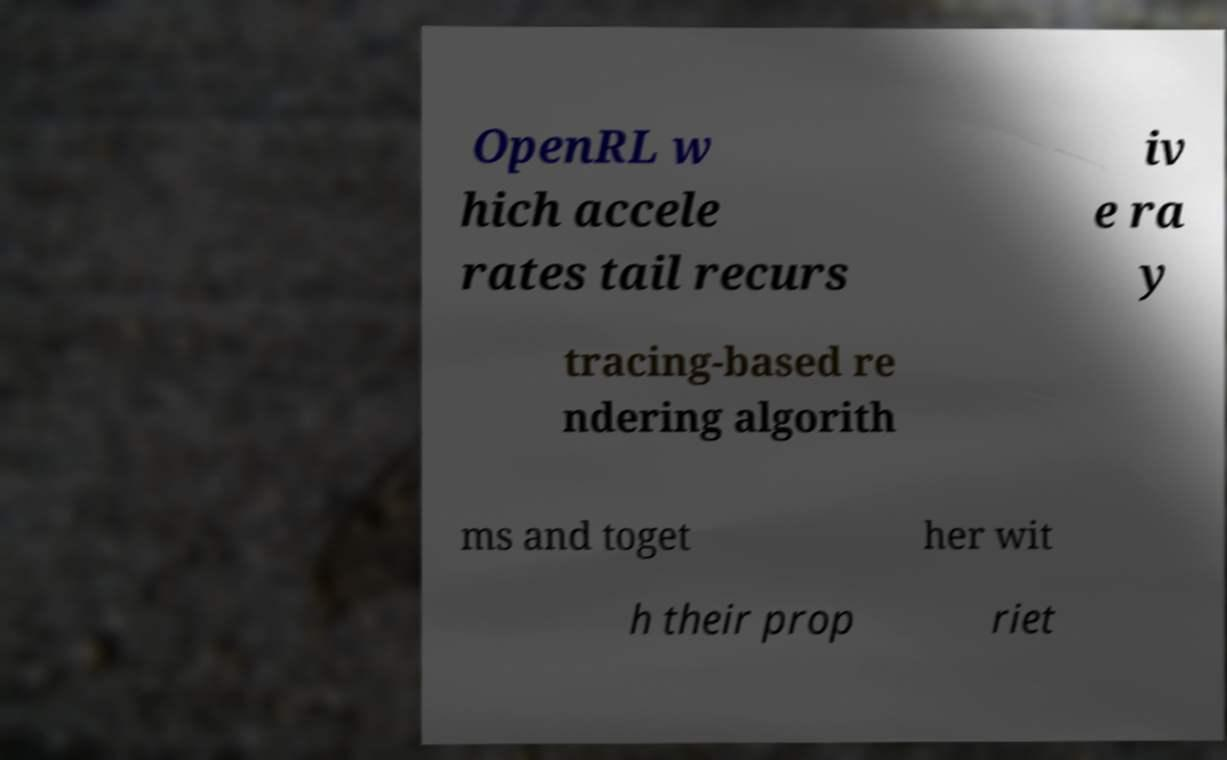Can you read and provide the text displayed in the image?This photo seems to have some interesting text. Can you extract and type it out for me? OpenRL w hich accele rates tail recurs iv e ra y tracing-based re ndering algorith ms and toget her wit h their prop riet 